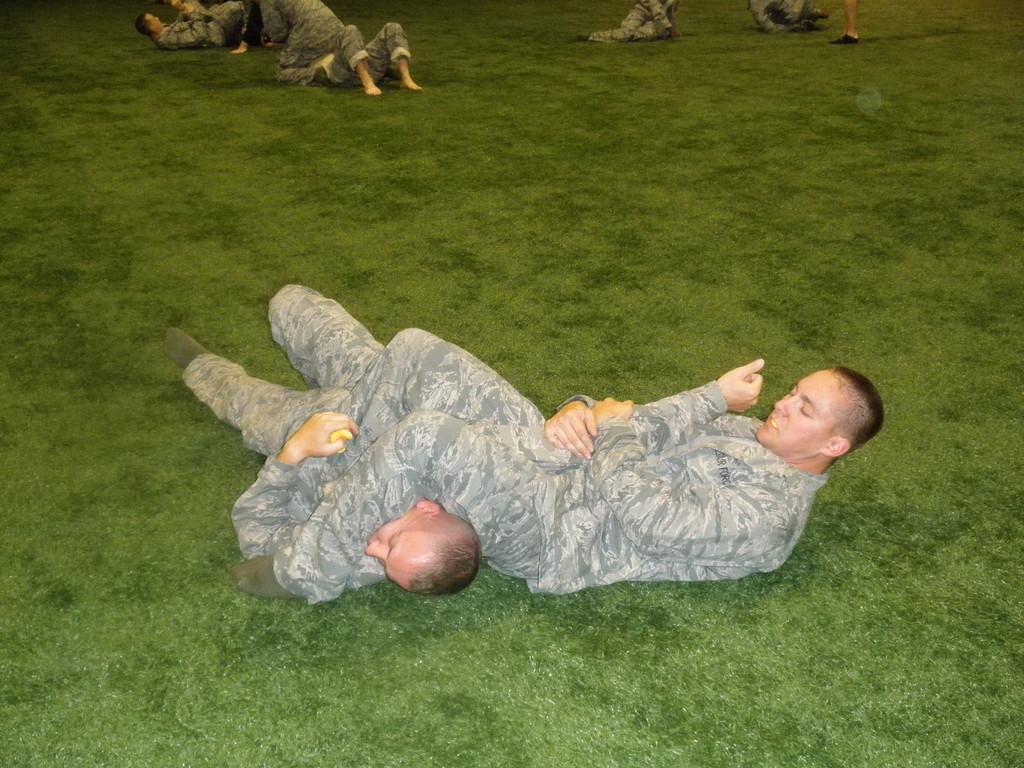In one or two sentences, can you explain what this image depicts? This picture describes about group of people, few are laying on the grass. 